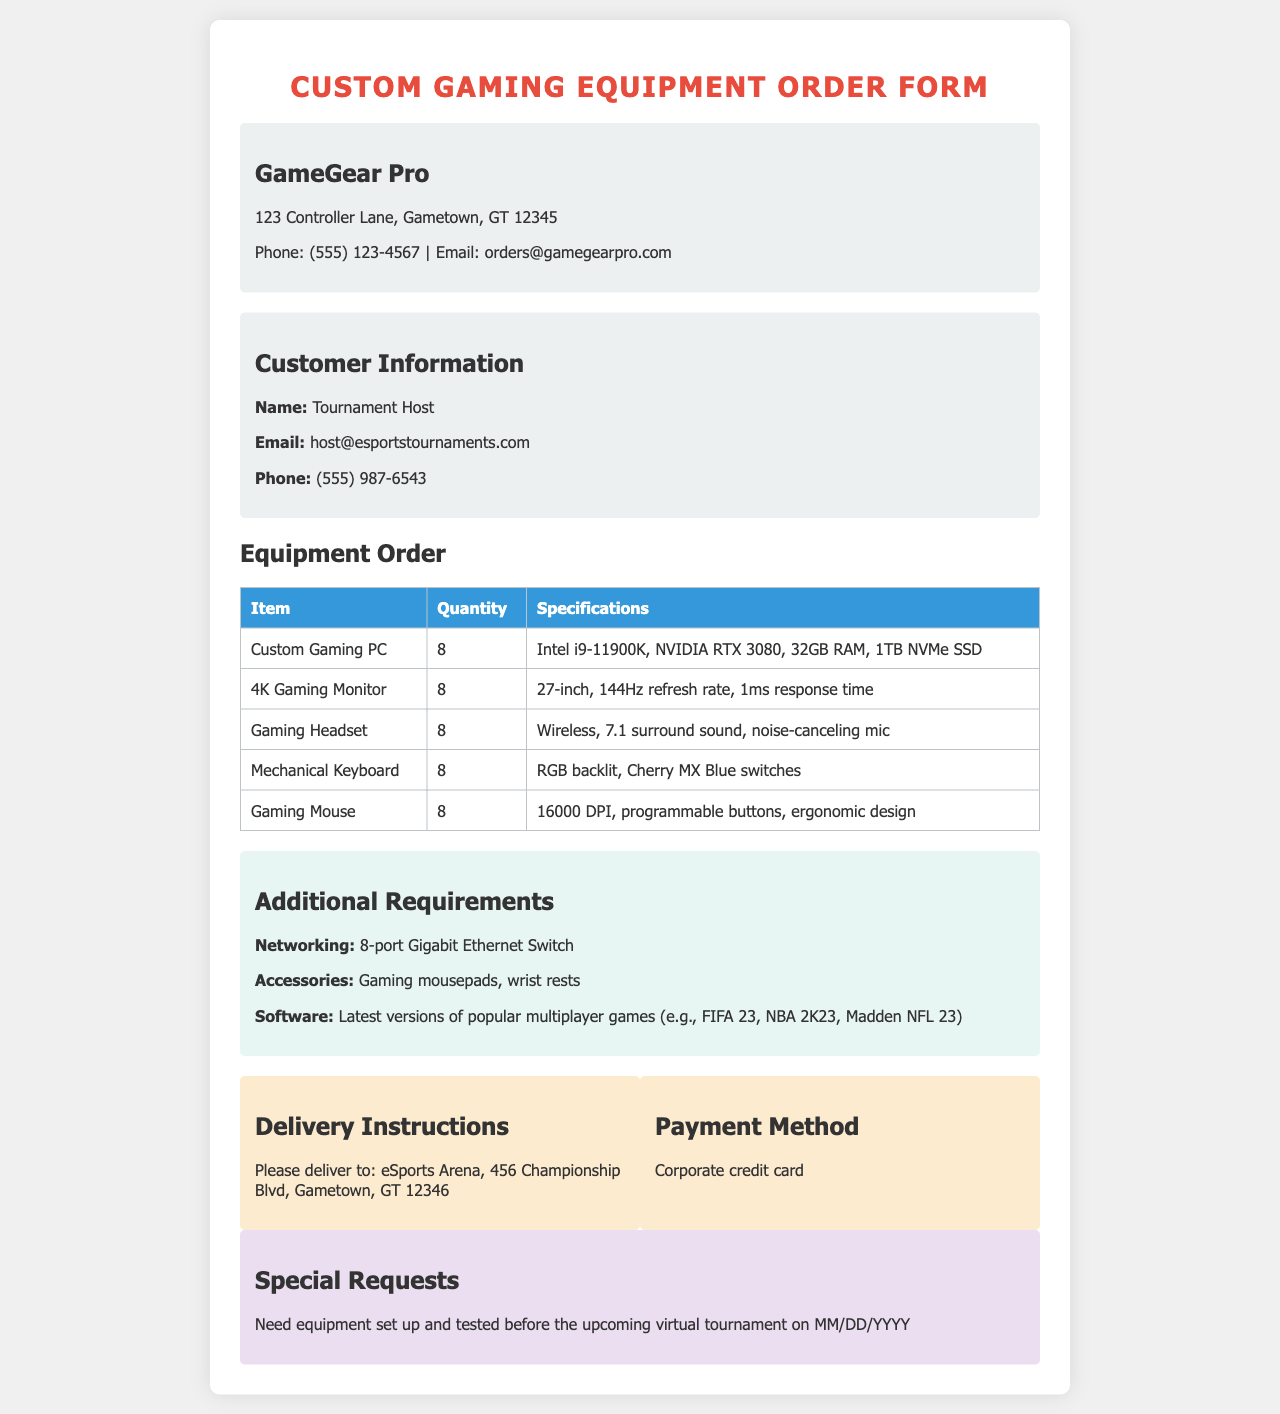What is the company name? The company that created the order form is identified at the top of the document.
Answer: GameGear Pro How many Custom Gaming PCs are ordered? The quantity of Custom Gaming PCs ordered is listed in the equipment table.
Answer: 8 What is the response time for the 4K Gaming Monitor? The response time for the monitor is specified in its specifications in the table.
Answer: 1ms What additional networking equipment is required? The additional requirements section lists the networking equipment needed for the setup.
Answer: 8-port Gigabit Ethernet Switch Where should the equipment be delivered? The delivery instructions specify the location for delivery in the document.
Answer: eSports Arena, 456 Championship Blvd, Gametown, GT 12346 What payment method is used? The document states the payment method to be used for the order.
Answer: Corporate credit card When is the upcoming virtual tournament? The special requests section includes the date for the upcoming event.
Answer: MM/DD/YYYY What specifications are required for the Gaming Mouse? The specifications for the Gaming Mouse are listed in the equipment order table.
Answer: 16000 DPI, programmable buttons, ergonomic design What type of games should be included with the software? The additional requirements list specifies the types of games needed for the multiplayer setup.
Answer: FIFA 23, NBA 2K23, Madden NFL 23 